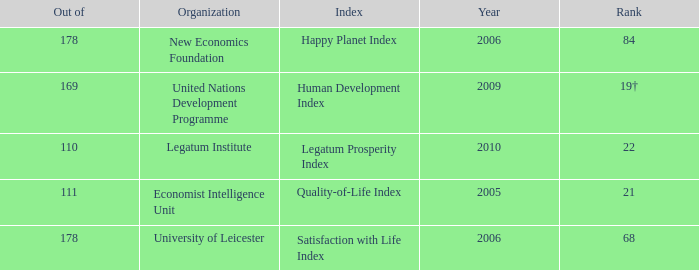What year is the happy planet index? 2006.0. 